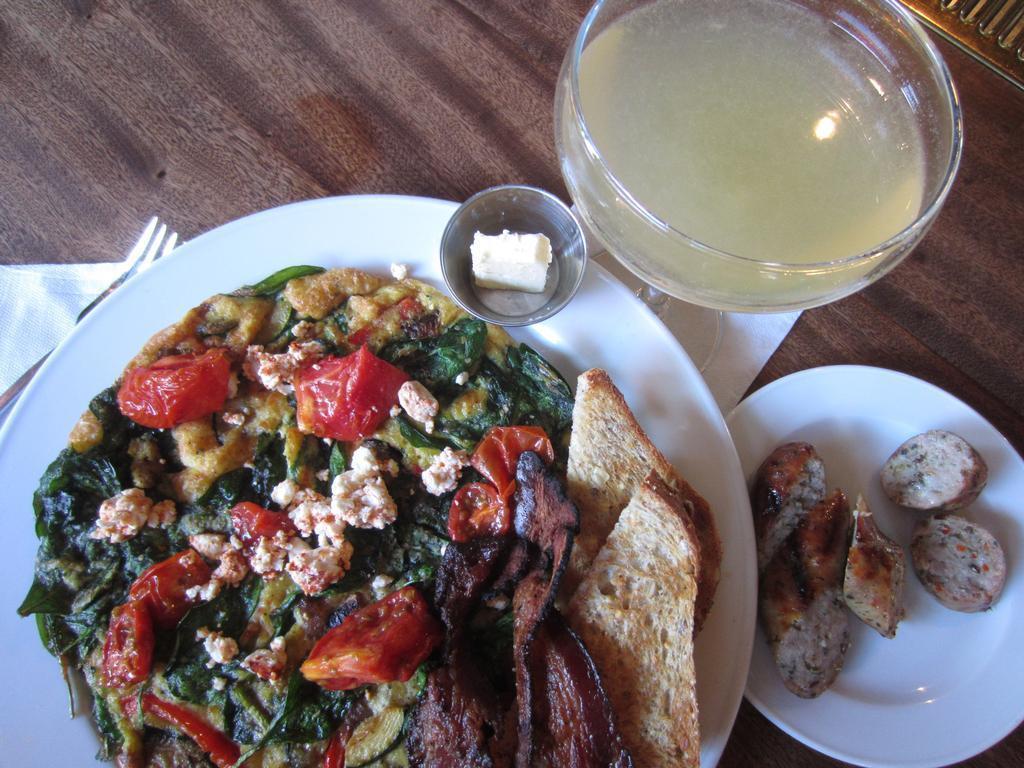How would you summarize this image in a sentence or two? In this image there is a table, on that table there are two plants, in that plates there is food item, beside that plates there is a blow, in that blow there is a liquid. 